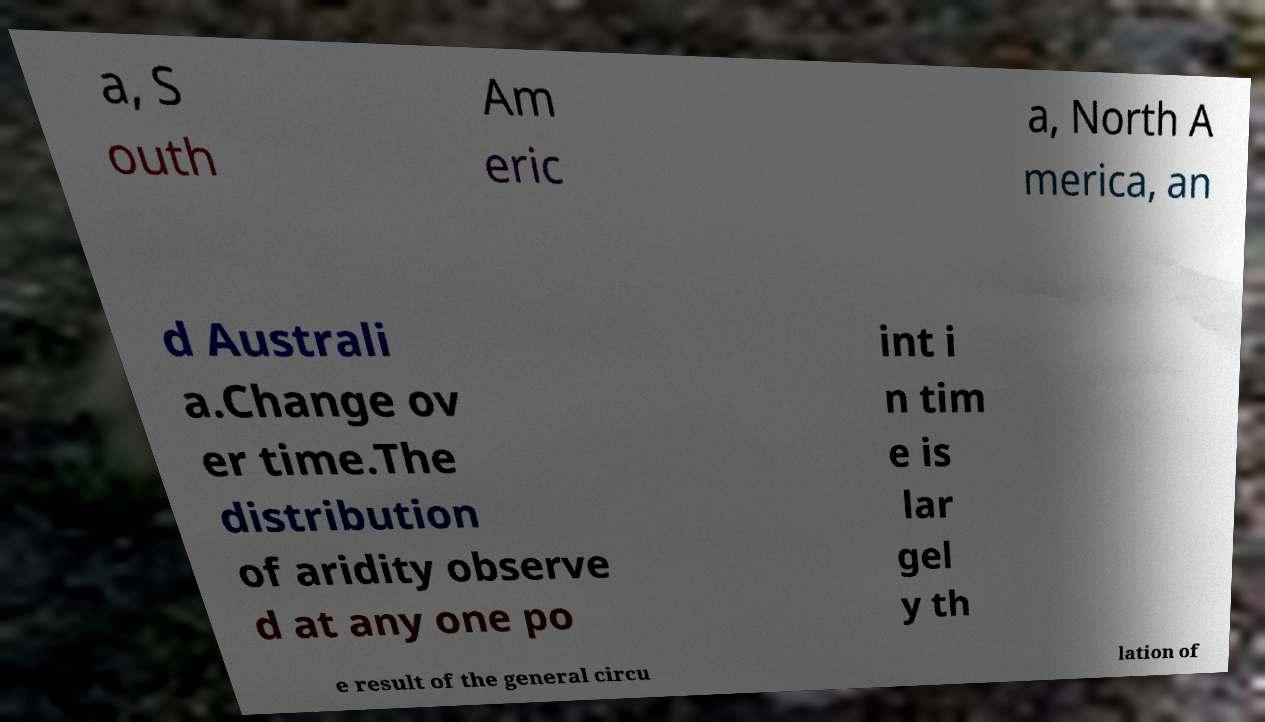I need the written content from this picture converted into text. Can you do that? a, S outh Am eric a, North A merica, an d Australi a.Change ov er time.The distribution of aridity observe d at any one po int i n tim e is lar gel y th e result of the general circu lation of 